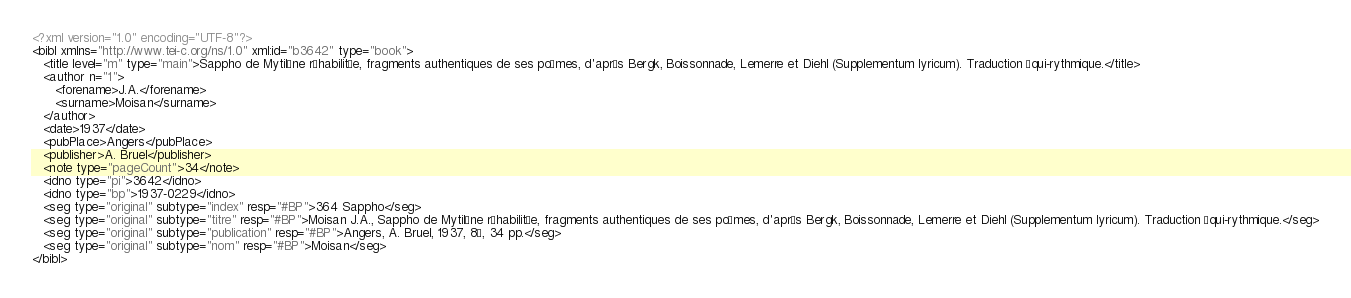Convert code to text. <code><loc_0><loc_0><loc_500><loc_500><_XML_><?xml version="1.0" encoding="UTF-8"?>
<bibl xmlns="http://www.tei-c.org/ns/1.0" xml:id="b3642" type="book">
   <title level="m" type="main">Sappho de Mytilène réhabilitée, fragments authentiques de ses poèmes, d'après Bergk, Boissonnade, Lemerre et Diehl (Supplementum lyricum). Traduction équi-rythmique.</title>
   <author n="1">
      <forename>J.A.</forename>
      <surname>Moisan</surname>
   </author>
   <date>1937</date>
   <pubPlace>Angers</pubPlace>
   <publisher>A. Bruel</publisher>
   <note type="pageCount">34</note>
   <idno type="pi">3642</idno>
   <idno type="bp">1937-0229</idno>
   <seg type="original" subtype="index" resp="#BP">364 Sappho</seg>
   <seg type="original" subtype="titre" resp="#BP">Moisan J.A., Sappho de Mytilène réhabilitée, fragments authentiques de ses poèmes, d'après Bergk, Boissonnade, Lemerre et Diehl (Supplementum lyricum). Traduction équi-rythmique.</seg>
   <seg type="original" subtype="publication" resp="#BP">Angers, A. Bruel, 1937, 8°, 34 pp.</seg>
   <seg type="original" subtype="nom" resp="#BP">Moisan</seg>
</bibl>
</code> 